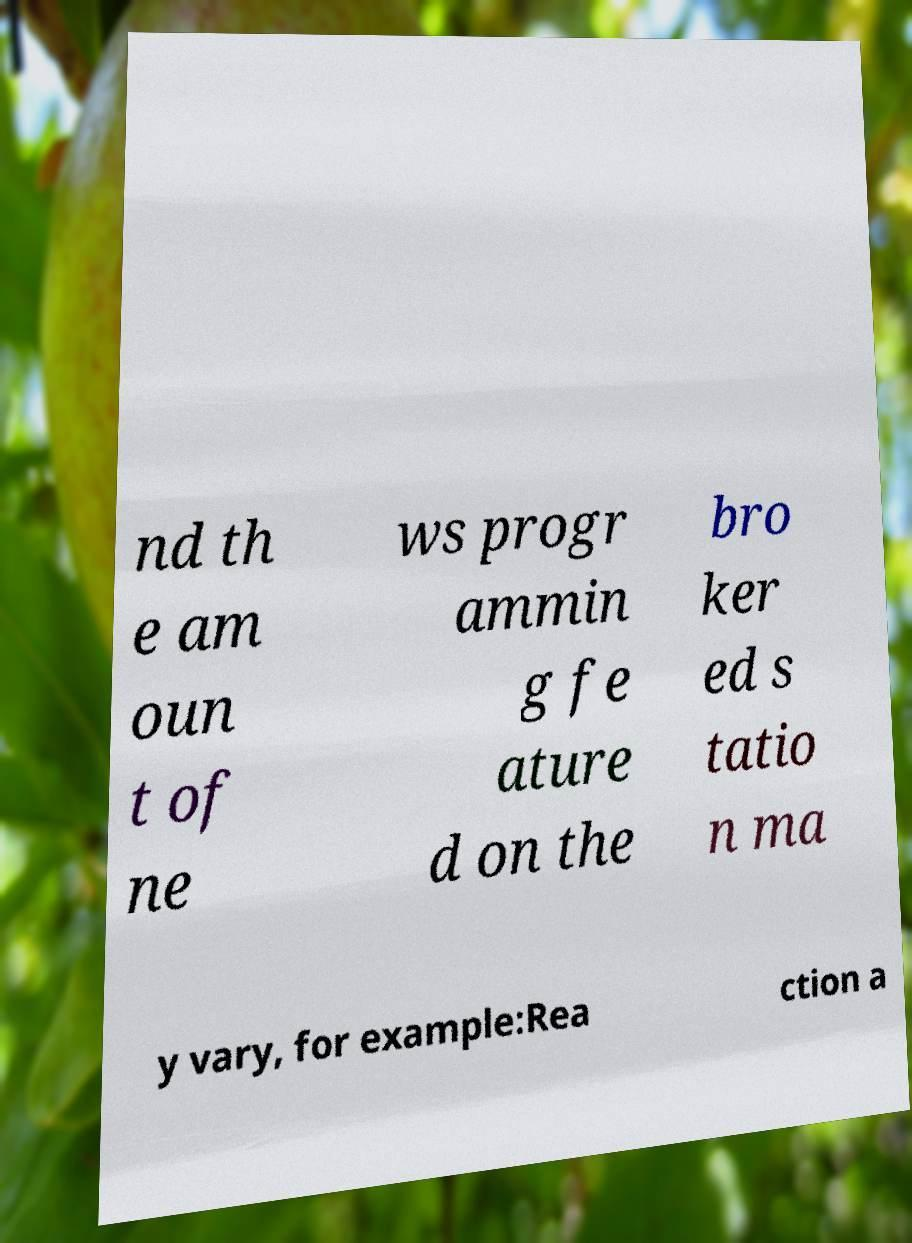There's text embedded in this image that I need extracted. Can you transcribe it verbatim? nd th e am oun t of ne ws progr ammin g fe ature d on the bro ker ed s tatio n ma y vary, for example:Rea ction a 